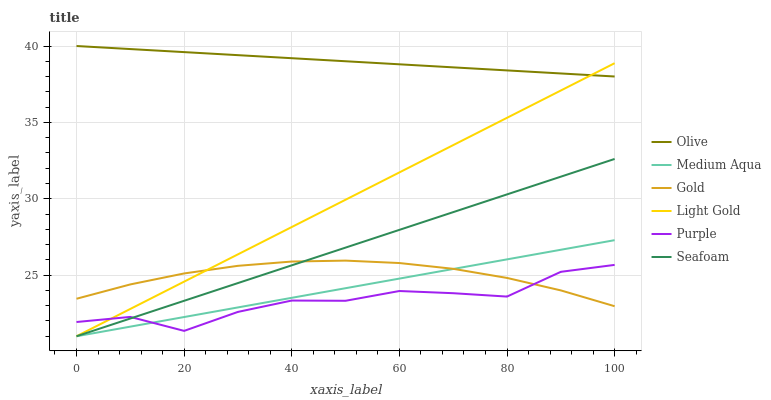Does Seafoam have the minimum area under the curve?
Answer yes or no. No. Does Seafoam have the maximum area under the curve?
Answer yes or no. No. Is Purple the smoothest?
Answer yes or no. No. Is Seafoam the roughest?
Answer yes or no. No. Does Purple have the lowest value?
Answer yes or no. No. Does Seafoam have the highest value?
Answer yes or no. No. Is Purple less than Olive?
Answer yes or no. Yes. Is Olive greater than Gold?
Answer yes or no. Yes. Does Purple intersect Olive?
Answer yes or no. No. 